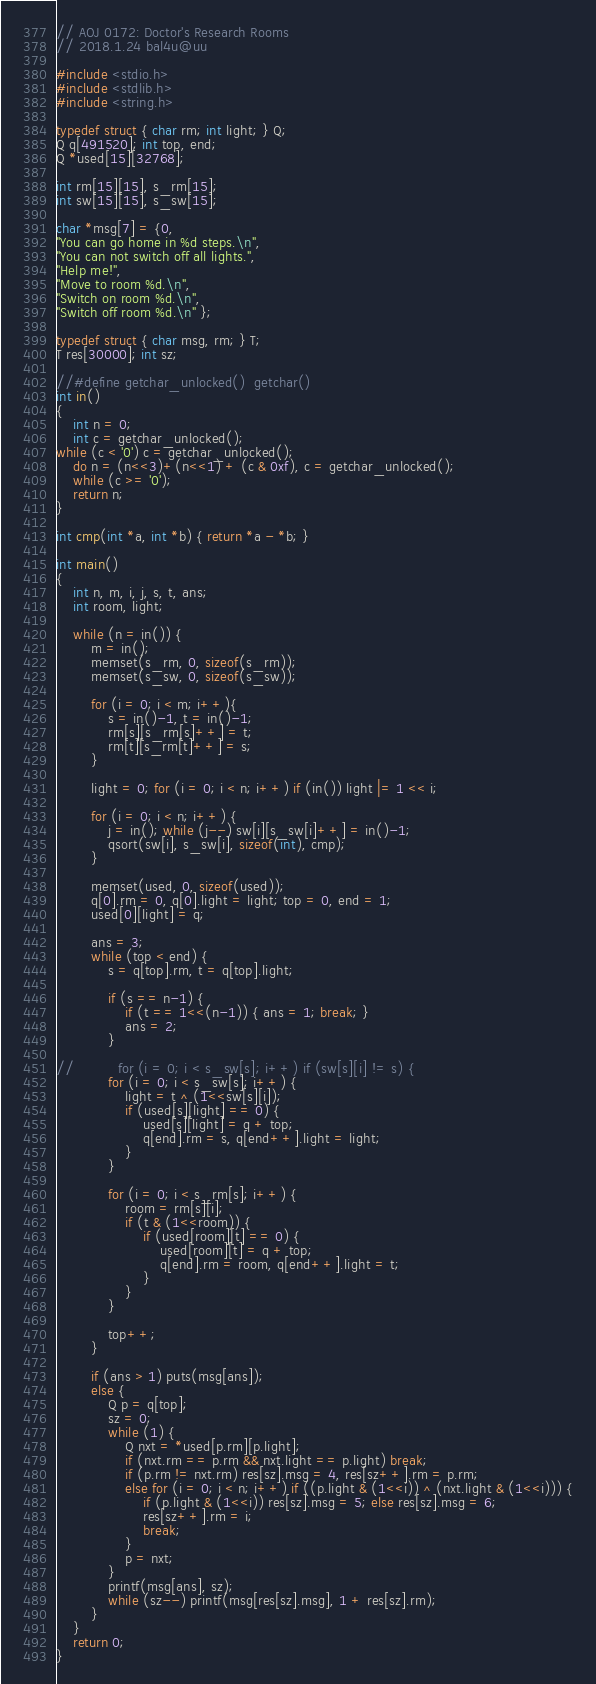<code> <loc_0><loc_0><loc_500><loc_500><_C_>// AOJ 0172: Doctor's Research Rooms
// 2018.1.24 bal4u@uu

#include <stdio.h>
#include <stdlib.h>
#include <string.h>

typedef struct { char rm; int light; } Q;
Q q[491520]; int top, end;
Q *used[15][32768];

int rm[15][15], s_rm[15];
int sw[15][15], s_sw[15];

char *msg[7] = {0,
"You can go home in %d steps.\n",
"You can not switch off all lights.",
"Help me!",
"Move to room %d.\n",
"Switch on room %d.\n",
"Switch off room %d.\n" };

typedef struct { char msg, rm; } T;
T res[30000]; int sz;

//#define getchar_unlocked()  getchar()
int in()
{
	int n = 0;
	int c = getchar_unlocked();
while (c < '0') c = getchar_unlocked();
	do n = (n<<3)+(n<<1) + (c & 0xf), c = getchar_unlocked();
	while (c >= '0');
	return n;
}

int cmp(int *a, int *b) { return *a - *b; }

int main()
{
	int n, m, i, j, s, t, ans;
	int room, light;

	while (n = in()) {
		m = in();
		memset(s_rm, 0, sizeof(s_rm));
		memset(s_sw, 0, sizeof(s_sw));

		for (i = 0; i < m; i++){
			s = in()-1, t = in()-1;
			rm[s][s_rm[s]++] = t;
			rm[t][s_rm[t]++] = s;
		}

		light = 0; for (i = 0; i < n; i++) if (in()) light |= 1 << i;

		for (i = 0; i < n; i++) {
			j = in(); while (j--) sw[i][s_sw[i]++] = in()-1;
			qsort(sw[i], s_sw[i], sizeof(int), cmp);
        }

		memset(used, 0, sizeof(used));
		q[0].rm = 0, q[0].light = light; top = 0, end = 1;
		used[0][light] = q;

		ans = 3;
		while (top < end) {
			s = q[top].rm, t = q[top].light;

			if (s == n-1) {
				if (t == 1<<(n-1)) { ans = 1; break; }
				ans = 2;
			}

//			for (i = 0; i < s_sw[s]; i++) if (sw[s][i] != s) {
			for (i = 0; i < s_sw[s]; i++) {
				light = t ^ (1<<sw[s][i]);
				if (used[s][light] == 0) {
					used[s][light] = q + top;
					q[end].rm = s, q[end++].light = light;
				}
			}

			for (i = 0; i < s_rm[s]; i++) {
				room = rm[s][i];
				if (t & (1<<room)) {
					if (used[room][t] == 0) {
						used[room][t] = q + top;
						q[end].rm = room, q[end++].light = t;
					}
				}
			}

			top++;
		}
 
		if (ans > 1) puts(msg[ans]);
		else {
			Q p = q[top];
			sz = 0;
			while (1) {
				Q nxt = *used[p.rm][p.light];
				if (nxt.rm == p.rm && nxt.light == p.light) break;
				if (p.rm != nxt.rm) res[sz].msg = 4, res[sz++].rm = p.rm;
				else for (i = 0; i < n; i++) if ((p.light & (1<<i)) ^ (nxt.light & (1<<i))) {
					if (p.light & (1<<i)) res[sz].msg = 5; else res[sz].msg = 6;
					res[sz++].rm = i;
					break;
				}
				p = nxt;
			}
			printf(msg[ans], sz);
			while (sz--) printf(msg[res[sz].msg], 1 + res[sz].rm);
		}
    }
    return 0;
}
</code> 